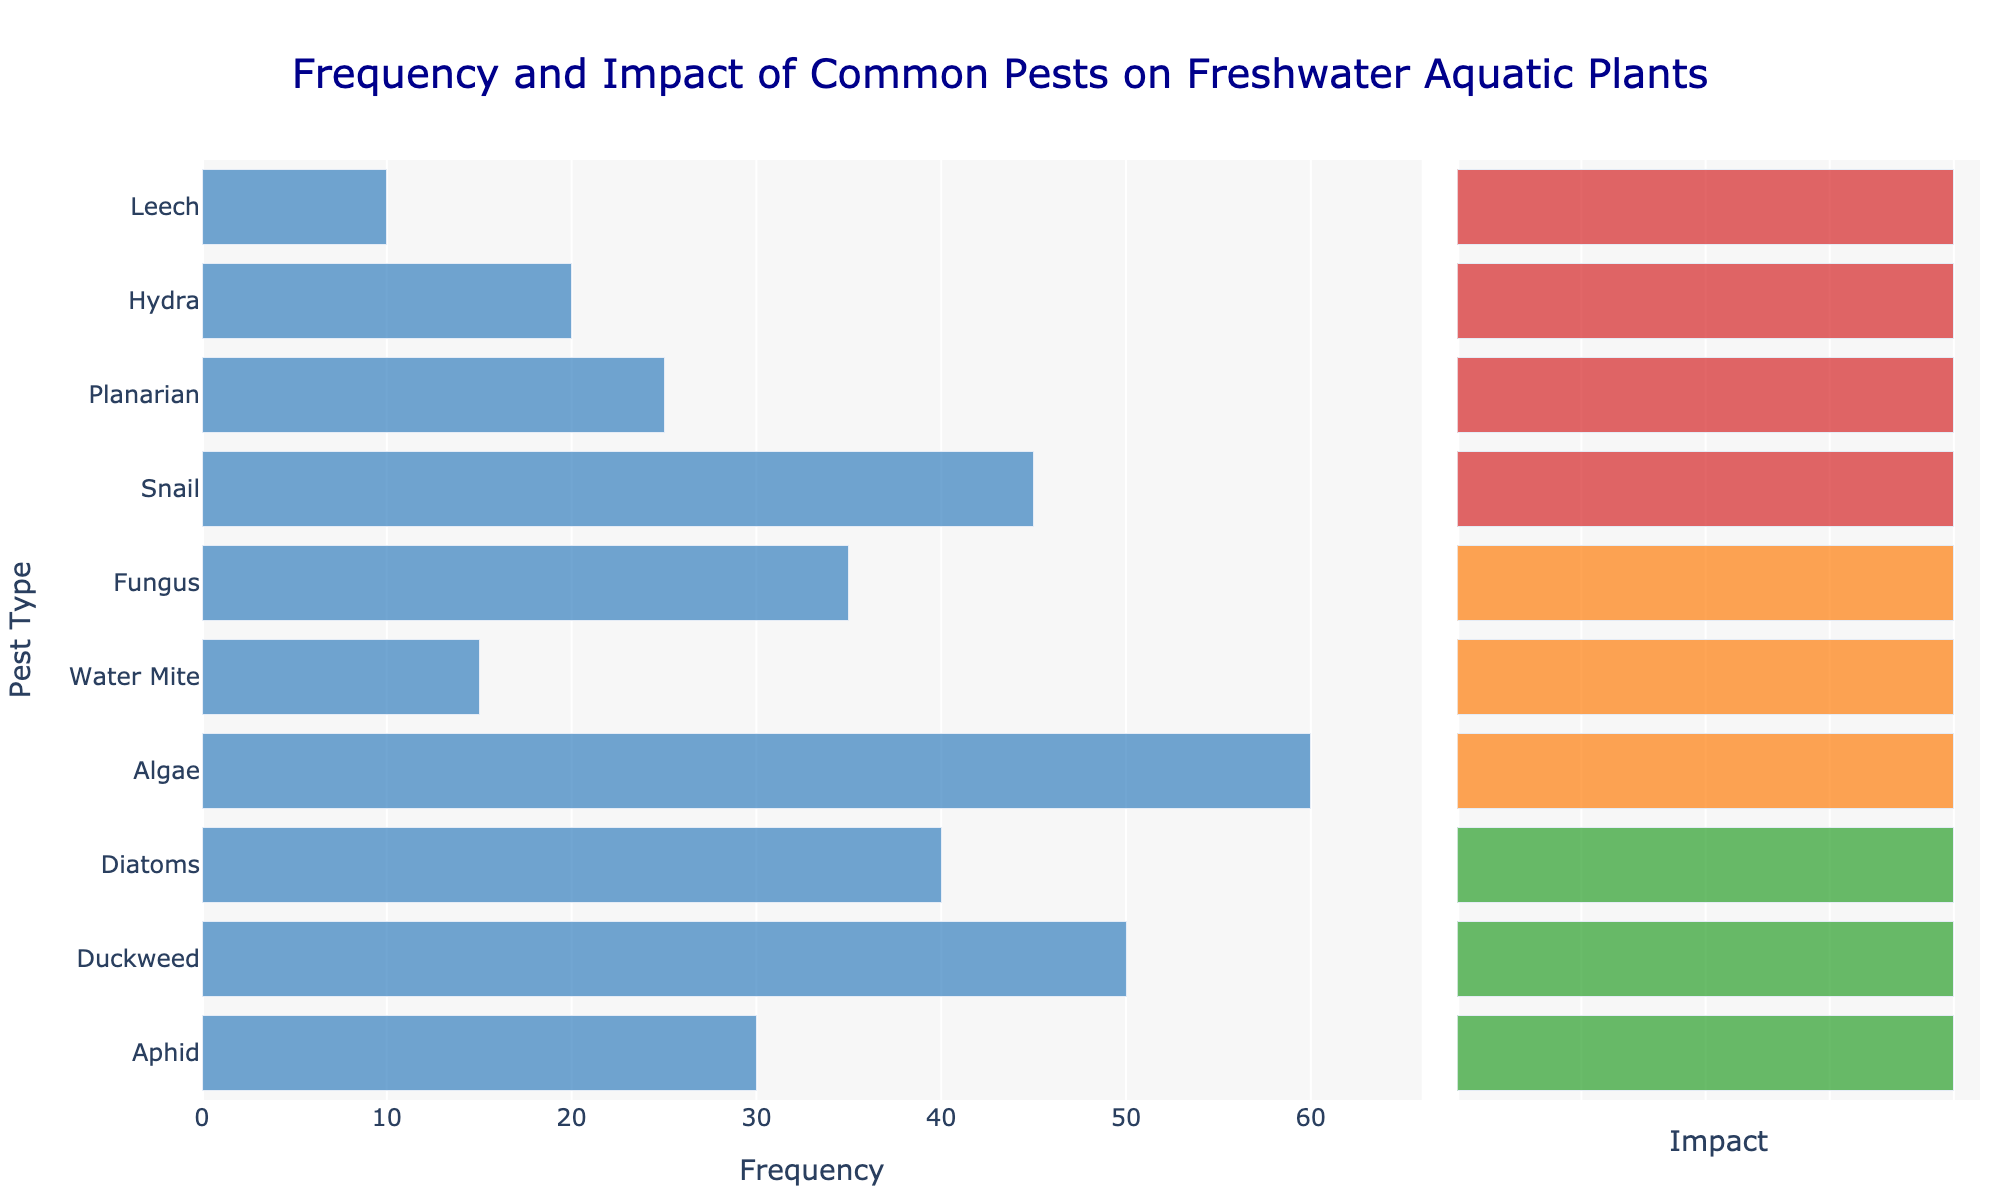Which pest has the highest frequency? To find the pest with the highest frequency, look at the length of the bars in the Frequency column on the left side of the chart. The pest with the longest bar is algae with a frequency of 60.
Answer: Algae How many pests have a high impact on plant health? To determine the number of pests with a high impact, refer to the colored bars in the Impact column on the right side of the chart. Count the number of red-colored bars. There are 4 pests: Snail, Planarian, Hydra, and Leech.
Answer: 4 What is the total frequency of pests with a medium impact on plant health? Sum the frequencies of pests marked with orange bars in the Impact column: Algae (60), Water Mite (15), and Fungus (35). The total is 60 + 15 + 35 = 110.
Answer: 110 Which pest with a high impact has the lowest frequency? Among pests with a high impact (colored red), compare their frequency bars. Leech has the lowest frequency with a value of 10.
Answer: Leech Compare the frequency of Diatoms and Aphids. Which one occurs more frequently? Locate the frequency bars for Diatoms and Aphids. Diatoms has a frequency of 40 while Aphids has a frequency of 30. Diatoms occurs more frequently.
Answer: Diatoms What is the frequency difference between the most frequent and the least frequent pest? The most frequent pest is Algae (frequency 60) and the least frequent is Leech (frequency 10). The difference is 60 - 10 = 50.
Answer: 50 Which type of pest has the highest representation in the dataset? Examine the "Type of Pest" data to determine which type appears most frequently. Plants appear three times (Algae, Duckweed, Diatoms), more than other categories.
Answer: Plant How many pests have an impact categorized as low? Count the number of green-colored bars in the Impact column. There are 3 pests: Aphid, Duckweed, and Diatoms.
Answer: 3 What is the average frequency of pests with a severe severity level? The pests with severe severity are Snail, Planarian, Hydra, and Leech with frequencies of 45, 25, 20, and 10 respectively. The average is (45 + 25 + 20 + 10) / 4 = 25.
Answer: 25 Which pest with a medium impact has the highest frequency? Among pests with a medium impact (colored orange), compare their frequency bars. Algae has the highest frequency with a value of 60.
Answer: Algae 